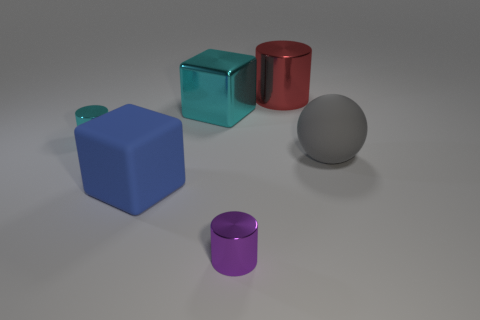What number of objects are either big green matte spheres or tiny cyan shiny objects?
Ensure brevity in your answer.  1. There is a matte thing that is to the right of the tiny metallic cylinder to the right of the big blue matte object; what is its size?
Keep it short and to the point. Large. The purple cylinder is what size?
Make the answer very short. Small. What shape is the big object that is on the left side of the large red metallic object and behind the big rubber cube?
Provide a succinct answer. Cube. The other shiny object that is the same shape as the blue object is what color?
Ensure brevity in your answer.  Cyan. What number of objects are either small cylinders right of the large cyan object or tiny metallic things that are on the left side of the tiny purple metallic cylinder?
Provide a short and direct response. 2. What is the shape of the big gray object?
Make the answer very short. Sphere. How many tiny objects are made of the same material as the big cylinder?
Keep it short and to the point. 2. The large sphere has what color?
Ensure brevity in your answer.  Gray. The metal block that is the same size as the gray matte thing is what color?
Give a very brief answer. Cyan. 